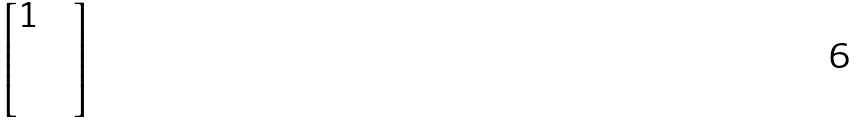<formula> <loc_0><loc_0><loc_500><loc_500>\begin{bmatrix} 1 & & \\ & & \\ & & \end{bmatrix}</formula> 